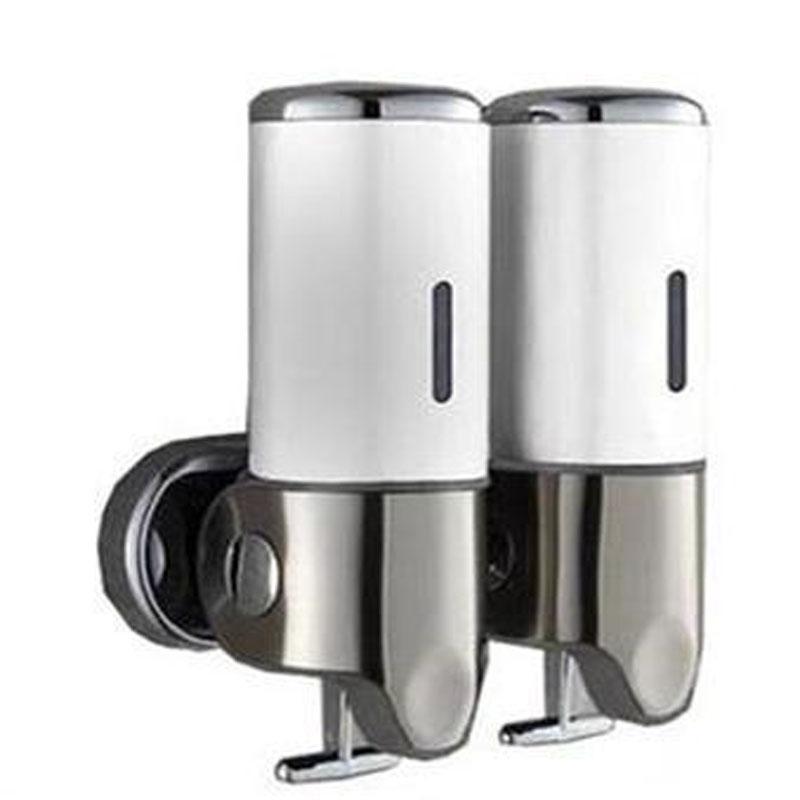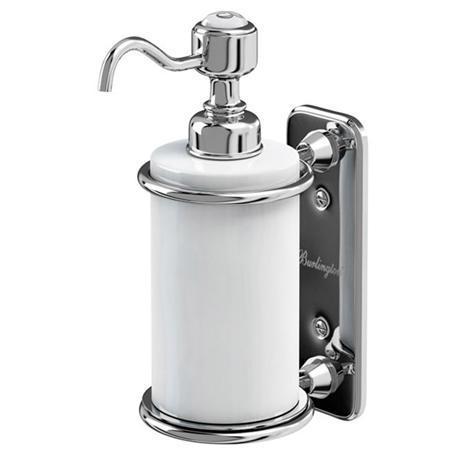The first image is the image on the left, the second image is the image on the right. Assess this claim about the two images: "A dispenser has a spout coming out from the top.". Correct or not? Answer yes or no. Yes. The first image is the image on the left, the second image is the image on the right. Considering the images on both sides, is "One image shows a cylindrical dispenser with a pump top and nozzle." valid? Answer yes or no. Yes. 